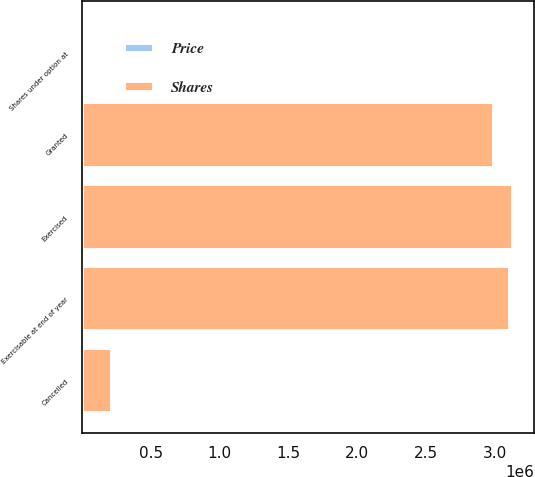Convert chart to OTSL. <chart><loc_0><loc_0><loc_500><loc_500><stacked_bar_chart><ecel><fcel>Shares under option at<fcel>Granted<fcel>Cancelled<fcel>Exercised<fcel>Exercisable at end of year<nl><fcel>Shares<fcel>48.59<fcel>2.993e+06<fcel>218560<fcel>3.13045e+06<fcel>3.11046e+06<nl><fcel>Price<fcel>29.12<fcel>48.59<fcel>30.9<fcel>27.08<fcel>26.17<nl></chart> 